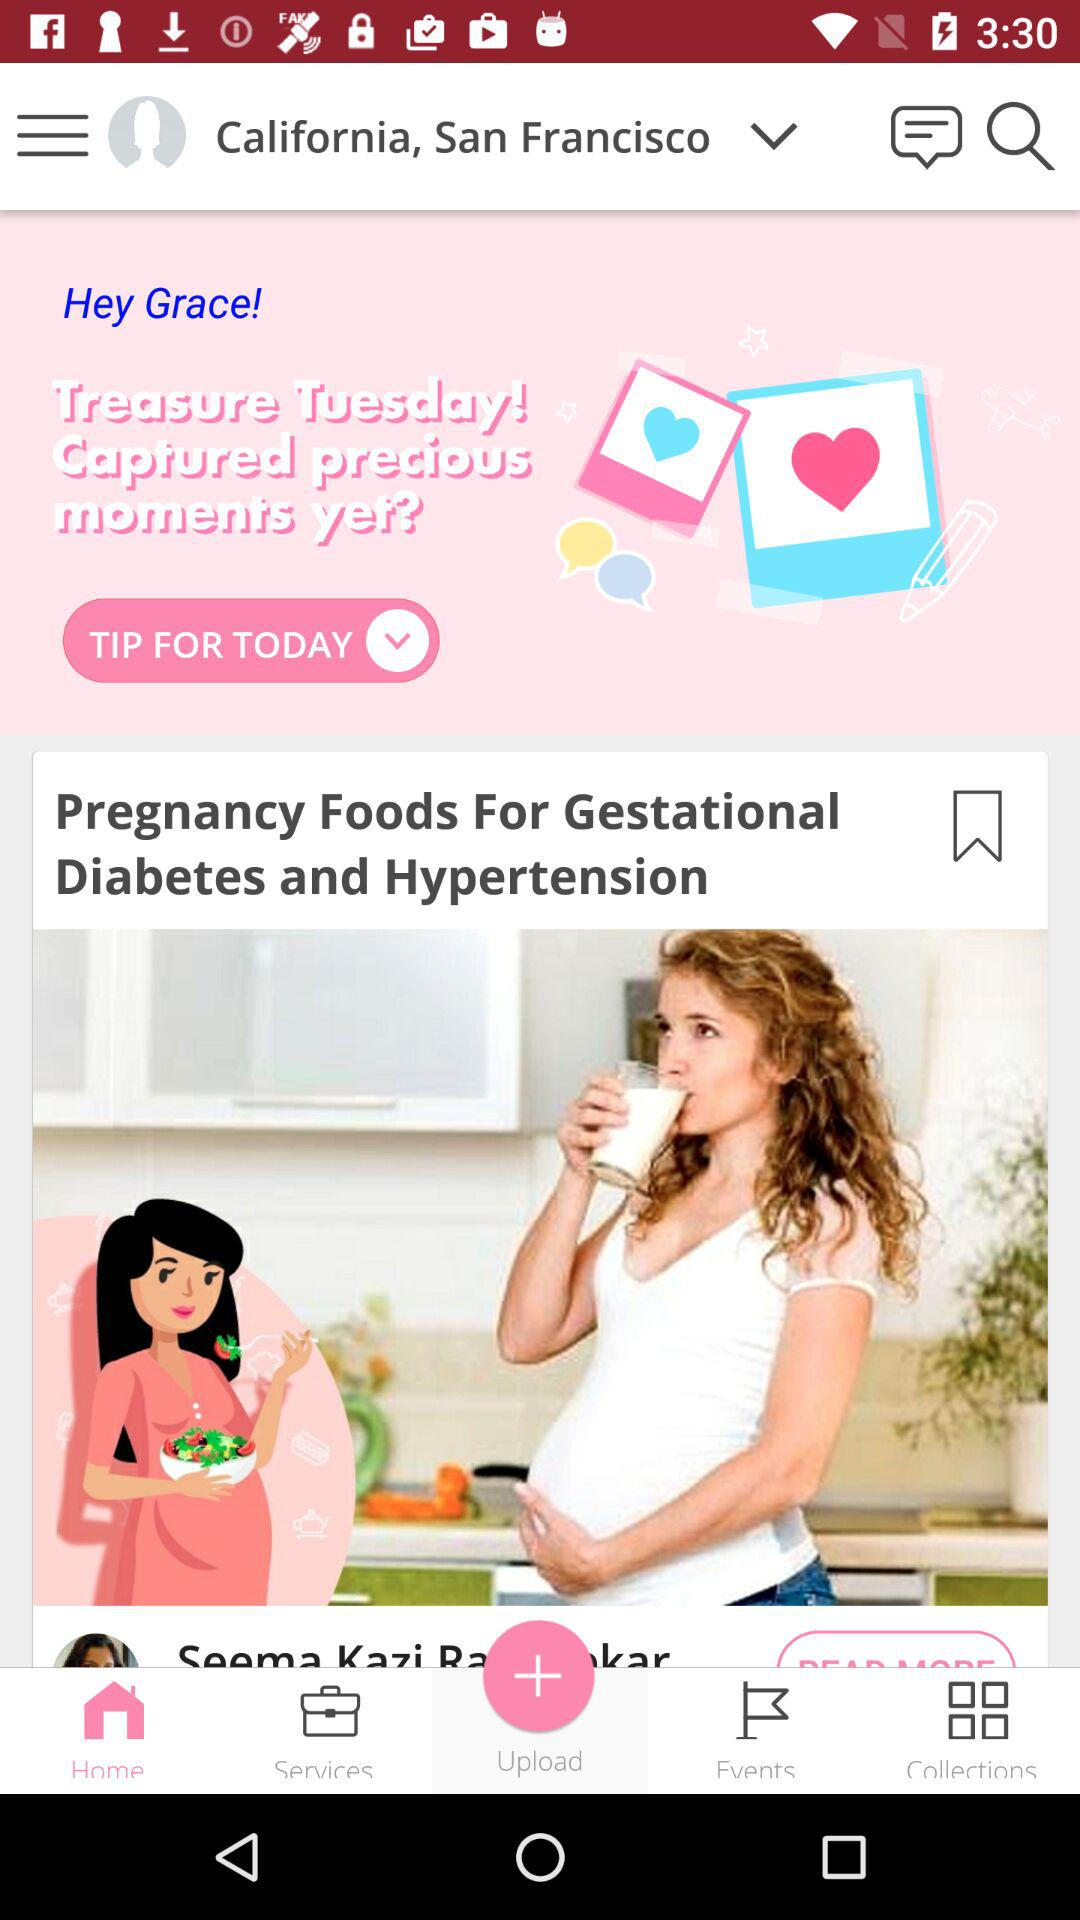What is the current location? The current location is California, San Francisco. 